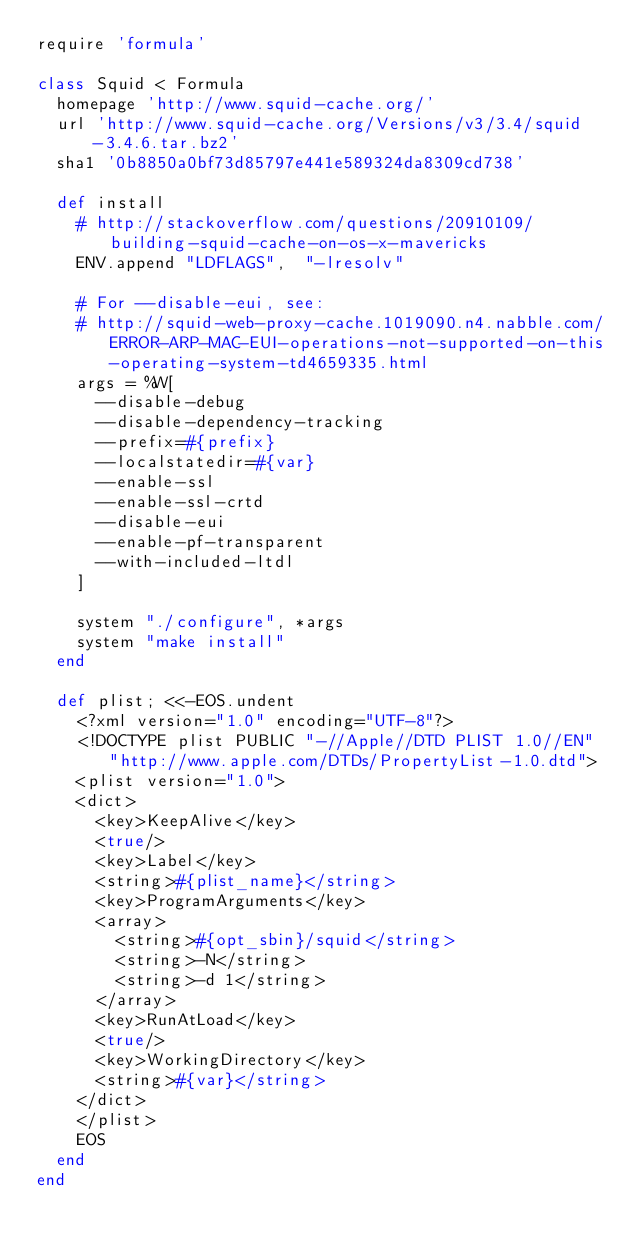Convert code to text. <code><loc_0><loc_0><loc_500><loc_500><_Ruby_>require 'formula'

class Squid < Formula
  homepage 'http://www.squid-cache.org/'
  url 'http://www.squid-cache.org/Versions/v3/3.4/squid-3.4.6.tar.bz2'
  sha1 '0b8850a0bf73d85797e441e589324da8309cd738'

  def install
    # http://stackoverflow.com/questions/20910109/building-squid-cache-on-os-x-mavericks
    ENV.append "LDFLAGS",  "-lresolv"

    # For --disable-eui, see:
    # http://squid-web-proxy-cache.1019090.n4.nabble.com/ERROR-ARP-MAC-EUI-operations-not-supported-on-this-operating-system-td4659335.html
    args = %W[
      --disable-debug
      --disable-dependency-tracking
      --prefix=#{prefix}
      --localstatedir=#{var}
      --enable-ssl
      --enable-ssl-crtd
      --disable-eui
      --enable-pf-transparent
      --with-included-ltdl
    ]

    system "./configure", *args
    system "make install"
  end

  def plist; <<-EOS.undent
    <?xml version="1.0" encoding="UTF-8"?>
    <!DOCTYPE plist PUBLIC "-//Apple//DTD PLIST 1.0//EN" "http://www.apple.com/DTDs/PropertyList-1.0.dtd">
    <plist version="1.0">
    <dict>
      <key>KeepAlive</key>
      <true/>
      <key>Label</key>
      <string>#{plist_name}</string>
      <key>ProgramArguments</key>
      <array>
        <string>#{opt_sbin}/squid</string>
        <string>-N</string>
        <string>-d 1</string>
      </array>
      <key>RunAtLoad</key>
      <true/>
      <key>WorkingDirectory</key>
      <string>#{var}</string>
    </dict>
    </plist>
    EOS
  end
end
</code> 